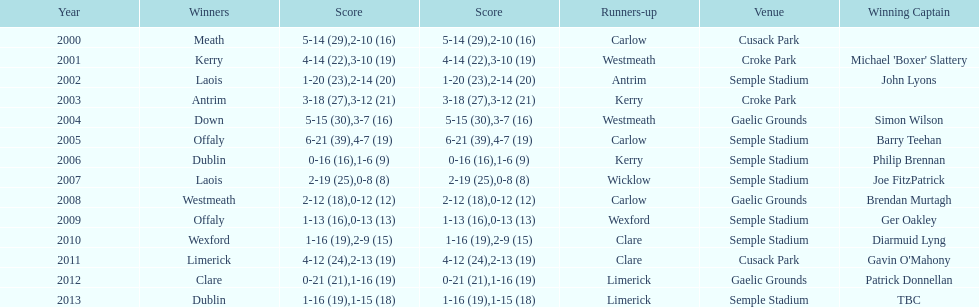Which team was the first to win with a team captain? Kerry. 